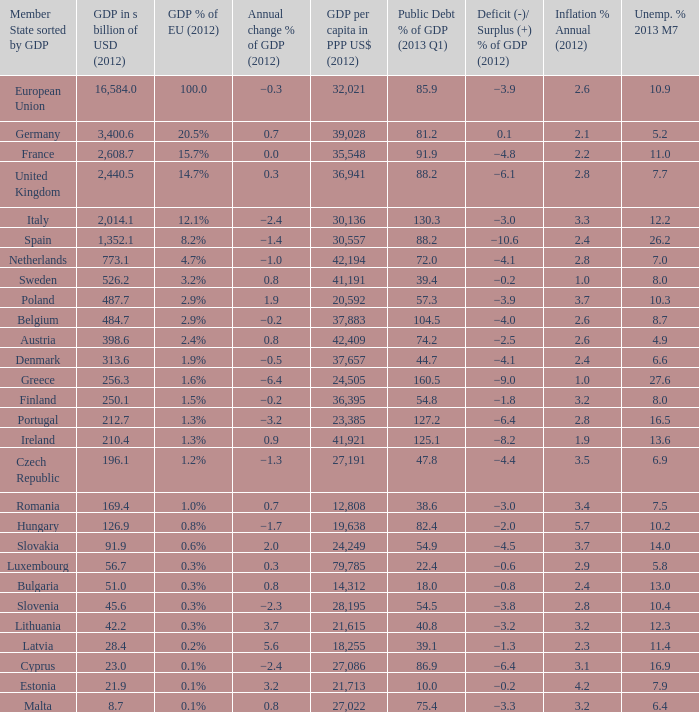What is the percentage of deficit/surplus in the 2012 gdp for a country that had a gdp below 1,352.1 billion usd, a gdp per capita in 2012 ppp usd above 21,615, a public debt % of gdp in q1 2013 lower than 75.4, and an annual inflation rate of 2.9% in 2012? −0.6. 